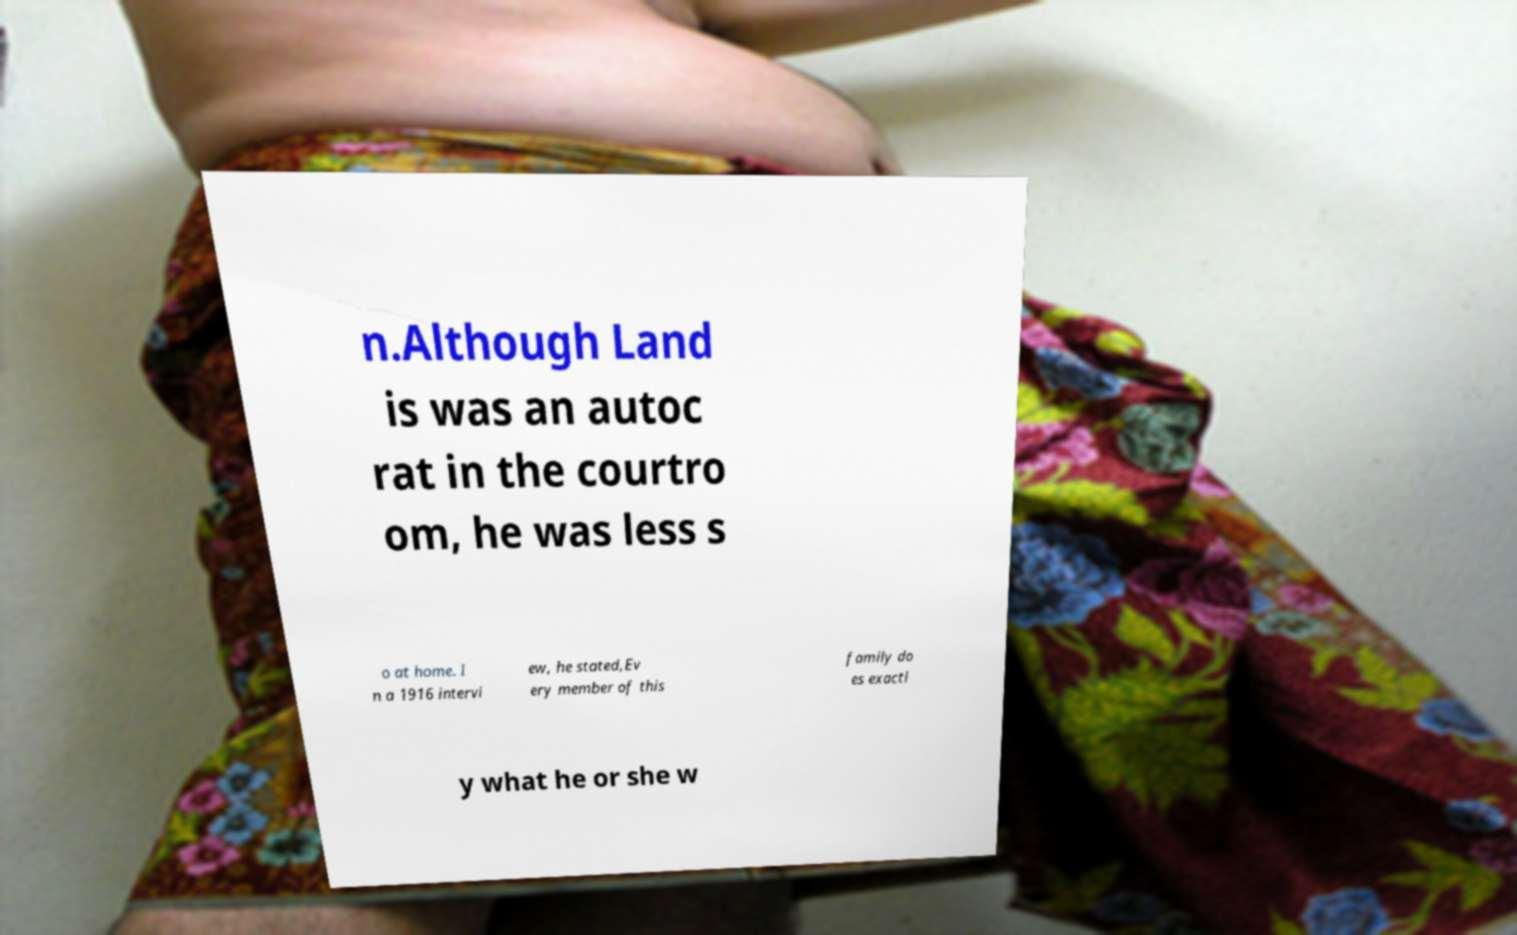There's text embedded in this image that I need extracted. Can you transcribe it verbatim? n.Although Land is was an autoc rat in the courtro om, he was less s o at home. I n a 1916 intervi ew, he stated,Ev ery member of this family do es exactl y what he or she w 